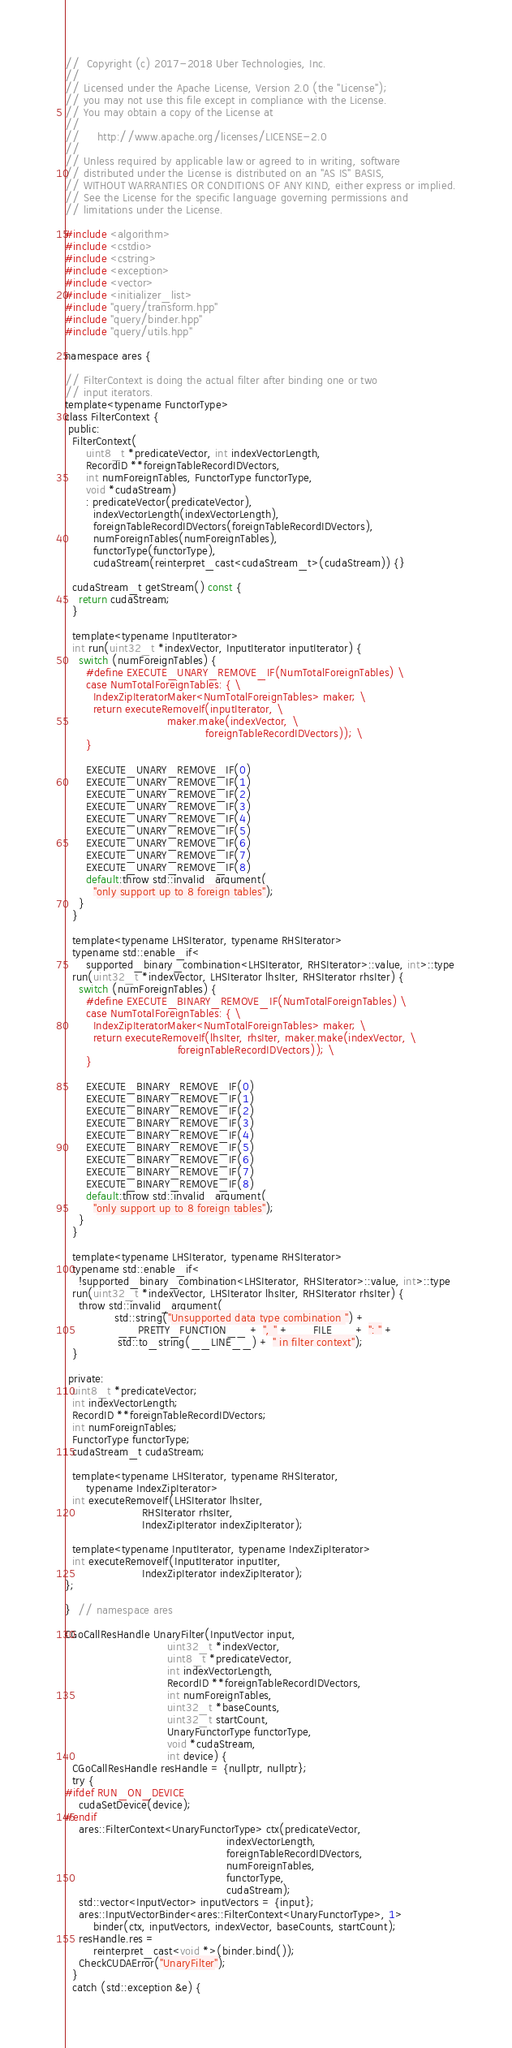Convert code to text. <code><loc_0><loc_0><loc_500><loc_500><_Cuda_>//  Copyright (c) 2017-2018 Uber Technologies, Inc.
//
// Licensed under the Apache License, Version 2.0 (the "License");
// you may not use this file except in compliance with the License.
// You may obtain a copy of the License at
//
//     http://www.apache.org/licenses/LICENSE-2.0
//
// Unless required by applicable law or agreed to in writing, software
// distributed under the License is distributed on an "AS IS" BASIS,
// WITHOUT WARRANTIES OR CONDITIONS OF ANY KIND, either express or implied.
// See the License for the specific language governing permissions and
// limitations under the License.

#include <algorithm>
#include <cstdio>
#include <cstring>
#include <exception>
#include <vector>
#include <initializer_list>
#include "query/transform.hpp"
#include "query/binder.hpp"
#include "query/utils.hpp"

namespace ares {

// FilterContext is doing the actual filter after binding one or two
// input iterators.
template<typename FunctorType>
class FilterContext {
 public:
  FilterContext(
      uint8_t *predicateVector, int indexVectorLength,
      RecordID **foreignTableRecordIDVectors,
      int numForeignTables, FunctorType functorType,
      void *cudaStream)
      : predicateVector(predicateVector),
        indexVectorLength(indexVectorLength),
        foreignTableRecordIDVectors(foreignTableRecordIDVectors),
        numForeignTables(numForeignTables),
        functorType(functorType),
        cudaStream(reinterpret_cast<cudaStream_t>(cudaStream)) {}

  cudaStream_t getStream() const {
    return cudaStream;
  }

  template<typename InputIterator>
  int run(uint32_t *indexVector, InputIterator inputIterator) {
    switch (numForeignTables) {
      #define EXECUTE_UNARY_REMOVE_IF(NumTotalForeignTables) \
      case NumTotalForeignTables: { \
        IndexZipIteratorMaker<NumTotalForeignTables> maker; \
        return executeRemoveIf(inputIterator, \
                             maker.make(indexVector, \
                                        foreignTableRecordIDVectors)); \
      }

      EXECUTE_UNARY_REMOVE_IF(0)
      EXECUTE_UNARY_REMOVE_IF(1)
      EXECUTE_UNARY_REMOVE_IF(2)
      EXECUTE_UNARY_REMOVE_IF(3)
      EXECUTE_UNARY_REMOVE_IF(4)
      EXECUTE_UNARY_REMOVE_IF(5)
      EXECUTE_UNARY_REMOVE_IF(6)
      EXECUTE_UNARY_REMOVE_IF(7)
      EXECUTE_UNARY_REMOVE_IF(8)
      default:throw std::invalid_argument(
        "only support up to 8 foreign tables");
    }
  }

  template<typename LHSIterator, typename RHSIterator>
  typename std::enable_if<
      supported_binary_combination<LHSIterator, RHSIterator>::value, int>::type
  run(uint32_t *indexVector, LHSIterator lhsIter, RHSIterator rhsIter) {
    switch (numForeignTables) {
      #define EXECUTE_BINARY_REMOVE_IF(NumTotalForeignTables) \
      case NumTotalForeignTables: { \
        IndexZipIteratorMaker<NumTotalForeignTables> maker; \
        return executeRemoveIf(lhsIter, rhsIter, maker.make(indexVector, \
                                foreignTableRecordIDVectors)); \
      }

      EXECUTE_BINARY_REMOVE_IF(0)
      EXECUTE_BINARY_REMOVE_IF(1)
      EXECUTE_BINARY_REMOVE_IF(2)
      EXECUTE_BINARY_REMOVE_IF(3)
      EXECUTE_BINARY_REMOVE_IF(4)
      EXECUTE_BINARY_REMOVE_IF(5)
      EXECUTE_BINARY_REMOVE_IF(6)
      EXECUTE_BINARY_REMOVE_IF(7)
      EXECUTE_BINARY_REMOVE_IF(8)
      default:throw std::invalid_argument(
        "only support up to 8 foreign tables");
    }
  }

  template<typename LHSIterator, typename RHSIterator>
  typename std::enable_if<
    !supported_binary_combination<LHSIterator, RHSIterator>::value, int>::type
  run(uint32_t *indexVector, LHSIterator lhsIter, RHSIterator rhsIter) {
    throw std::invalid_argument(
              std::string("Unsupported data type combination ") +
               __PRETTY_FUNCTION__ + ", " + __FILE__ + ": " +
               std::to_string(__LINE__) + " in filter context");
  }

 private:
  uint8_t *predicateVector;
  int indexVectorLength;
  RecordID **foreignTableRecordIDVectors;
  int numForeignTables;
  FunctorType functorType;
  cudaStream_t cudaStream;

  template<typename LHSIterator, typename RHSIterator,
      typename IndexZipIterator>
  int executeRemoveIf(LHSIterator lhsIter,
                      RHSIterator rhsIter,
                      IndexZipIterator indexZipIterator);

  template<typename InputIterator, typename IndexZipIterator>
  int executeRemoveIf(InputIterator inputIter,
                      IndexZipIterator indexZipIterator);
};

}  // namespace ares

CGoCallResHandle UnaryFilter(InputVector input,
                             uint32_t *indexVector,
                             uint8_t *predicateVector,
                             int indexVectorLength,
                             RecordID **foreignTableRecordIDVectors,
                             int numForeignTables,
                             uint32_t *baseCounts,
                             uint32_t startCount,
                             UnaryFunctorType functorType,
                             void *cudaStream,
                             int device) {
  CGoCallResHandle resHandle = {nullptr, nullptr};
  try {
#ifdef RUN_ON_DEVICE
    cudaSetDevice(device);
#endif
    ares::FilterContext<UnaryFunctorType> ctx(predicateVector,
                                              indexVectorLength,
                                              foreignTableRecordIDVectors,
                                              numForeignTables,
                                              functorType,
                                              cudaStream);
    std::vector<InputVector> inputVectors = {input};
    ares::InputVectorBinder<ares::FilterContext<UnaryFunctorType>, 1>
        binder(ctx, inputVectors, indexVector, baseCounts, startCount);
    resHandle.res =
        reinterpret_cast<void *>(binder.bind());
    CheckCUDAError("UnaryFilter");
  }
  catch (std::exception &e) {</code> 